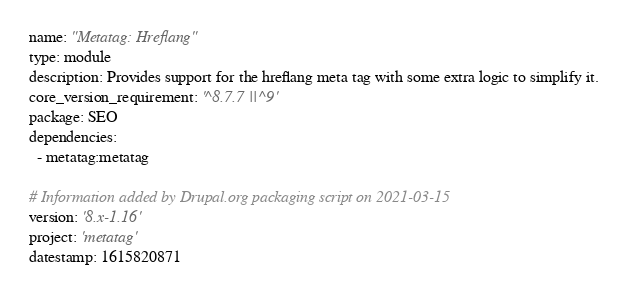Convert code to text. <code><loc_0><loc_0><loc_500><loc_500><_YAML_>name: "Metatag: Hreflang"
type: module
description: Provides support for the hreflang meta tag with some extra logic to simplify it.
core_version_requirement: '^8.7.7 || ^9'
package: SEO
dependencies:
  - metatag:metatag

# Information added by Drupal.org packaging script on 2021-03-15
version: '8.x-1.16'
project: 'metatag'
datestamp: 1615820871
</code> 